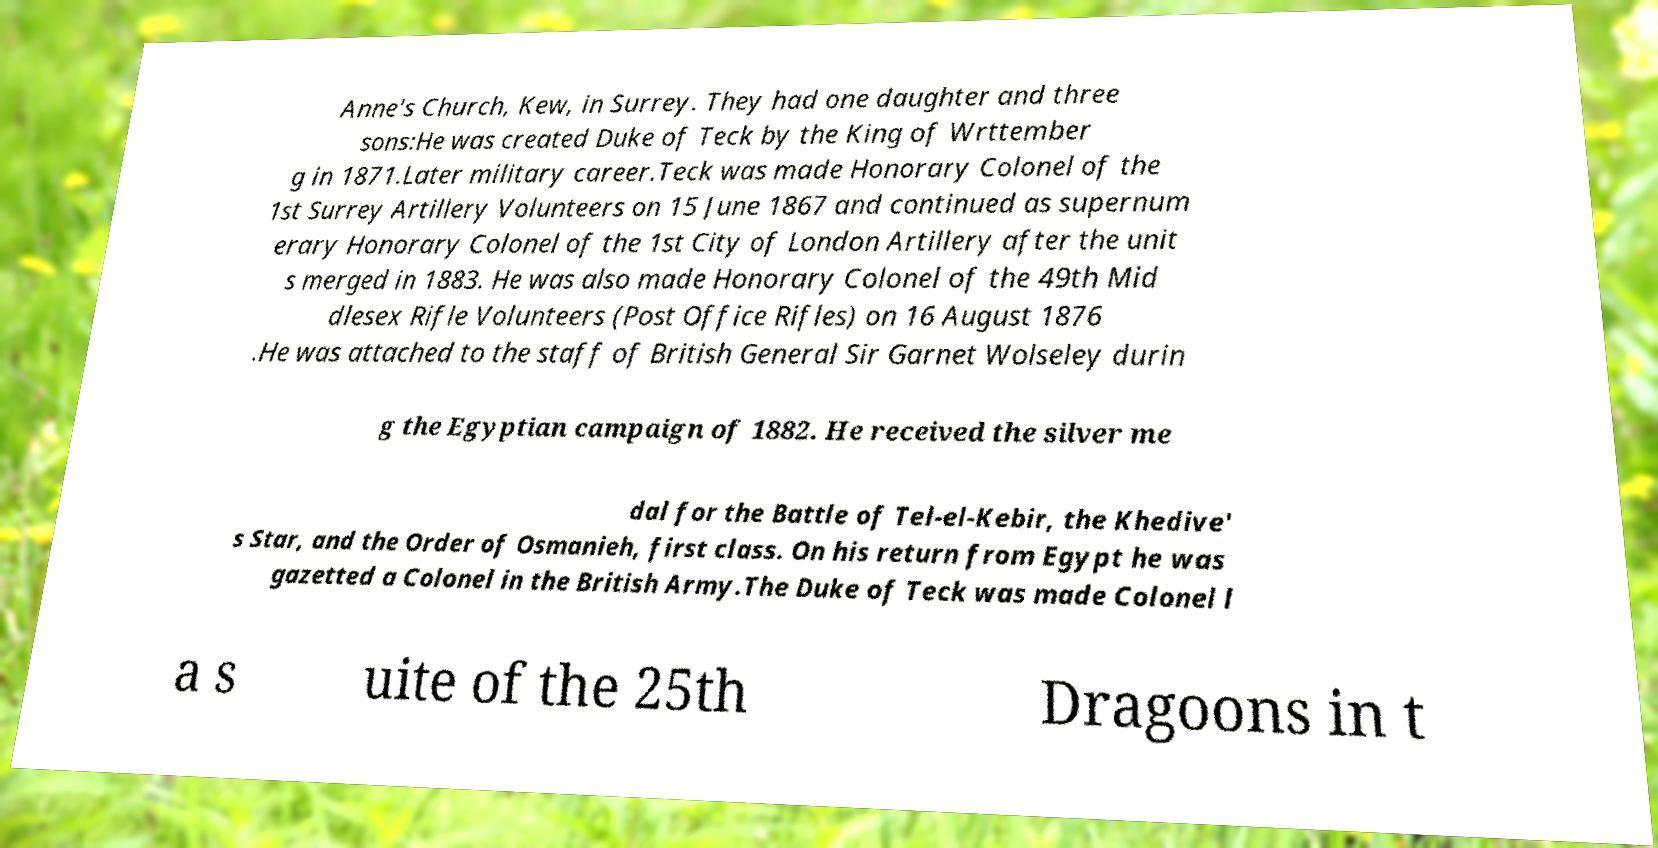I need the written content from this picture converted into text. Can you do that? Anne's Church, Kew, in Surrey. They had one daughter and three sons:He was created Duke of Teck by the King of Wrttember g in 1871.Later military career.Teck was made Honorary Colonel of the 1st Surrey Artillery Volunteers on 15 June 1867 and continued as supernum erary Honorary Colonel of the 1st City of London Artillery after the unit s merged in 1883. He was also made Honorary Colonel of the 49th Mid dlesex Rifle Volunteers (Post Office Rifles) on 16 August 1876 .He was attached to the staff of British General Sir Garnet Wolseley durin g the Egyptian campaign of 1882. He received the silver me dal for the Battle of Tel-el-Kebir, the Khedive' s Star, and the Order of Osmanieh, first class. On his return from Egypt he was gazetted a Colonel in the British Army.The Duke of Teck was made Colonel l a s uite of the 25th Dragoons in t 